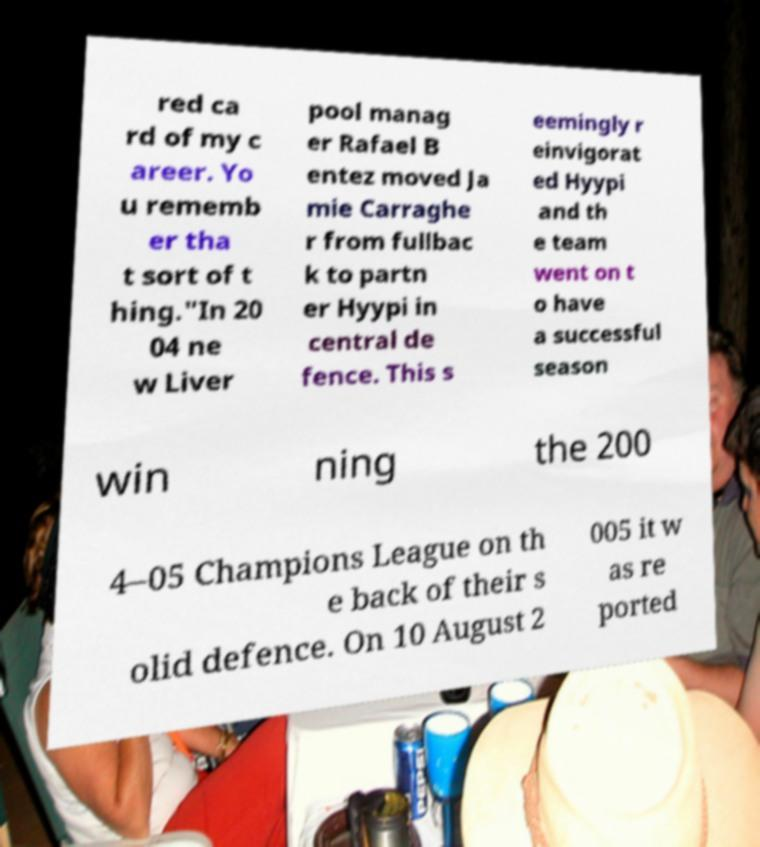Can you accurately transcribe the text from the provided image for me? red ca rd of my c areer. Yo u rememb er tha t sort of t hing."In 20 04 ne w Liver pool manag er Rafael B entez moved Ja mie Carraghe r from fullbac k to partn er Hyypi in central de fence. This s eemingly r einvigorat ed Hyypi and th e team went on t o have a successful season win ning the 200 4–05 Champions League on th e back of their s olid defence. On 10 August 2 005 it w as re ported 